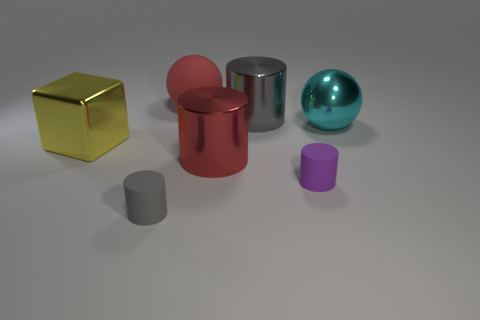Does the gray shiny object have the same shape as the purple rubber thing?
Offer a terse response. Yes. What shape is the gray thing that is made of the same material as the purple cylinder?
Offer a very short reply. Cylinder. There is a red thing in front of the big gray thing; is its size the same as the matte cylinder in front of the purple rubber cylinder?
Make the answer very short. No. Are there more big cyan shiny balls that are to the left of the gray shiny cylinder than gray matte cylinders that are behind the metal sphere?
Give a very brief answer. No. What number of other objects are there of the same color as the rubber sphere?
Give a very brief answer. 1. There is a big matte sphere; does it have the same color as the large cylinder behind the yellow object?
Give a very brief answer. No. There is a gray cylinder that is behind the yellow block; how many objects are in front of it?
Your response must be concise. 5. Are there any other things that have the same material as the yellow thing?
Offer a terse response. Yes. What material is the small cylinder that is to the right of the gray cylinder behind the red thing in front of the rubber sphere made of?
Your answer should be compact. Rubber. What material is the cylinder that is in front of the cyan ball and behind the small purple cylinder?
Your response must be concise. Metal. 